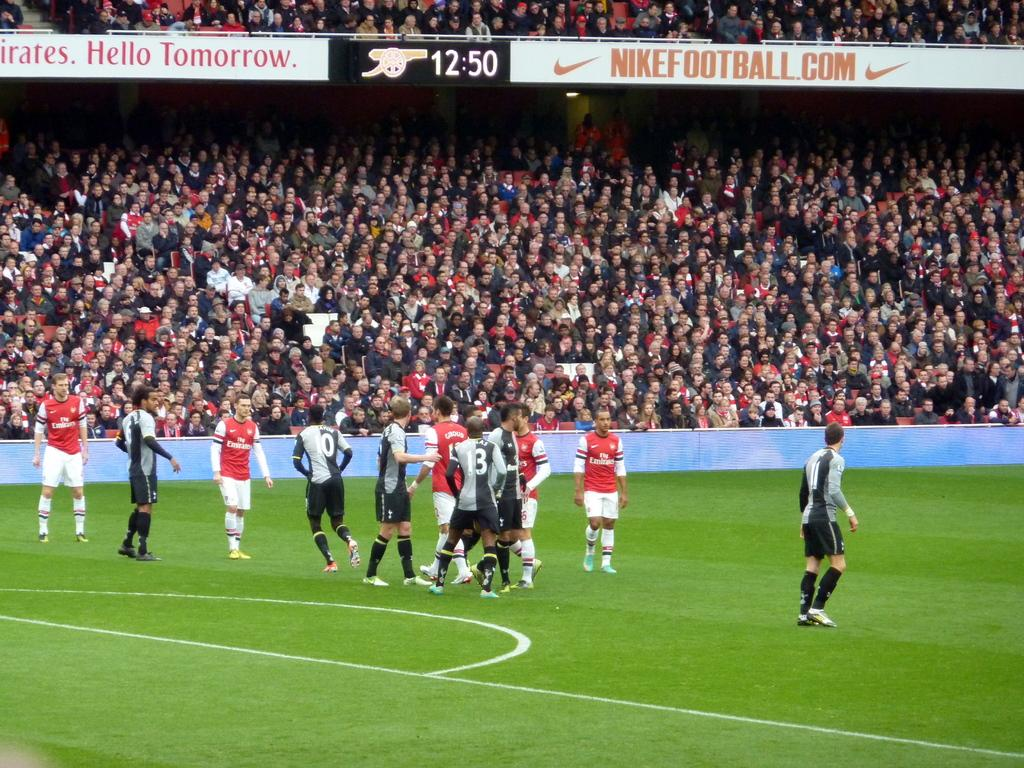<image>
Share a concise interpretation of the image provided. A soccer game is being played in a full stadium sponsored by NIKEFOOTBALL.COM. 